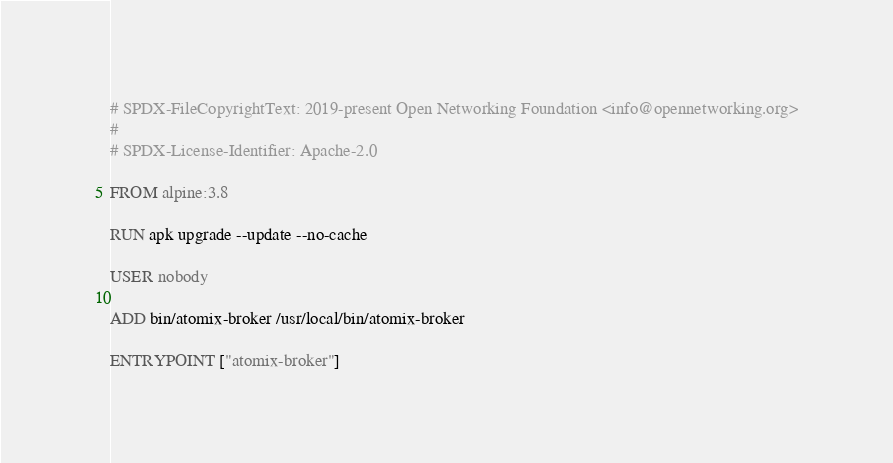Convert code to text. <code><loc_0><loc_0><loc_500><loc_500><_Dockerfile_># SPDX-FileCopyrightText: 2019-present Open Networking Foundation <info@opennetworking.org>
#
# SPDX-License-Identifier: Apache-2.0

FROM alpine:3.8

RUN apk upgrade --update --no-cache

USER nobody

ADD bin/atomix-broker /usr/local/bin/atomix-broker

ENTRYPOINT ["atomix-broker"]
</code> 